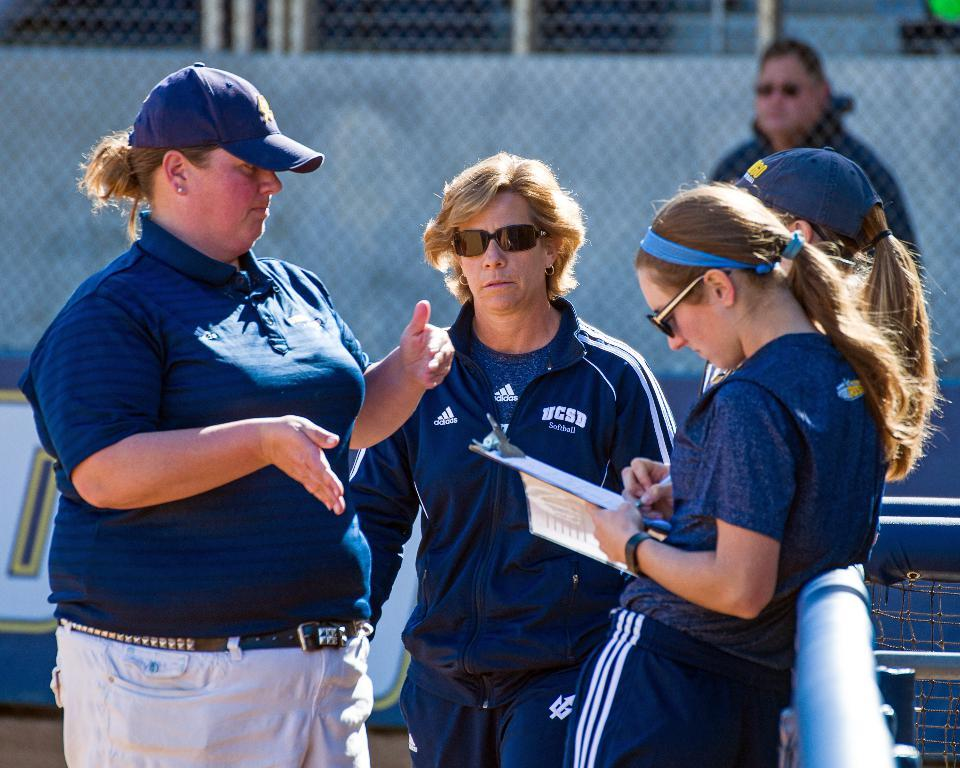<image>
Relay a brief, clear account of the picture shown. A woman in sunglasses wears a jacket which sports the UCSB Softball logo. 